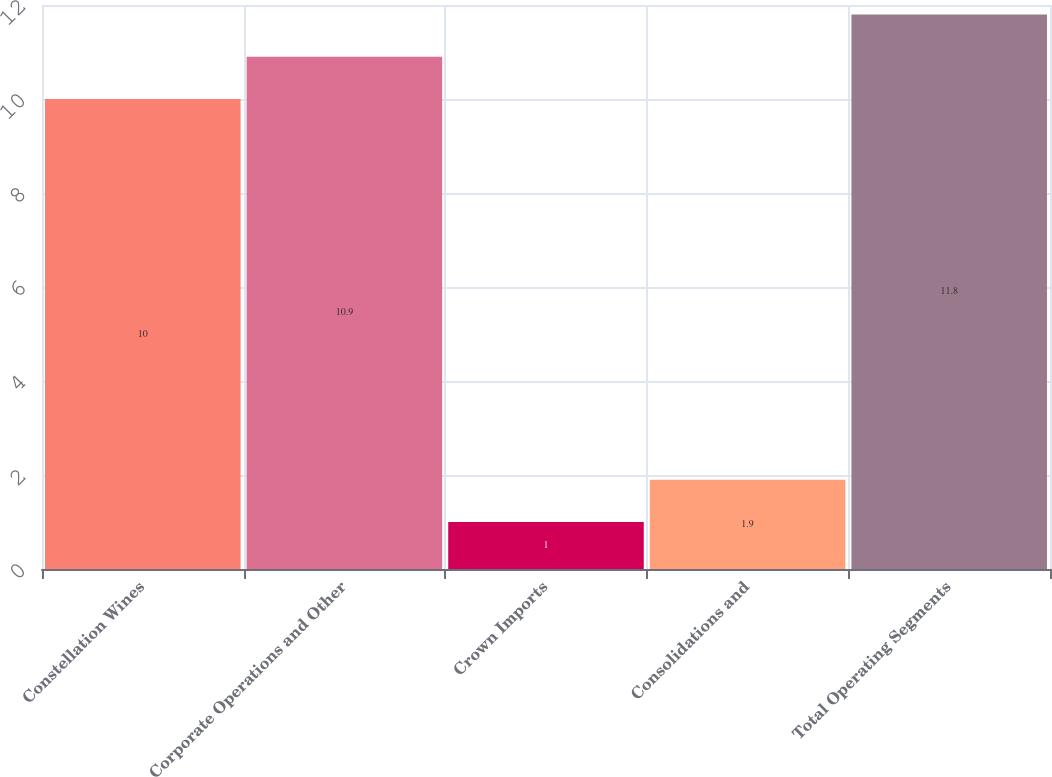Convert chart to OTSL. <chart><loc_0><loc_0><loc_500><loc_500><bar_chart><fcel>Constellation Wines<fcel>Corporate Operations and Other<fcel>Crown Imports<fcel>Consolidations and<fcel>Total Operating Segments<nl><fcel>10<fcel>10.9<fcel>1<fcel>1.9<fcel>11.8<nl></chart> 